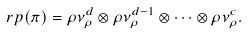Convert formula to latex. <formula><loc_0><loc_0><loc_500><loc_500>\ r p ( \pi ) = \rho \nu _ { \rho } ^ { d } \otimes \rho \nu _ { \rho } ^ { d - 1 } \otimes \dots \otimes \rho \nu _ { \rho } ^ { c } .</formula> 